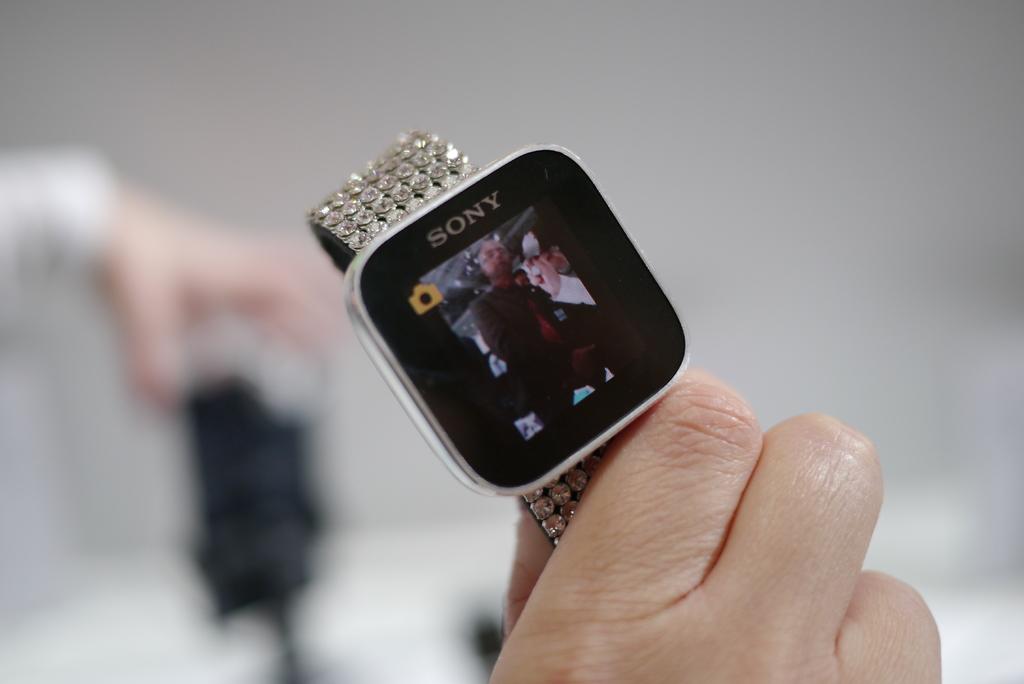What brand of smart watch is it?
Make the answer very short. Sony. What brand of watch is this?
Give a very brief answer. Sony. 